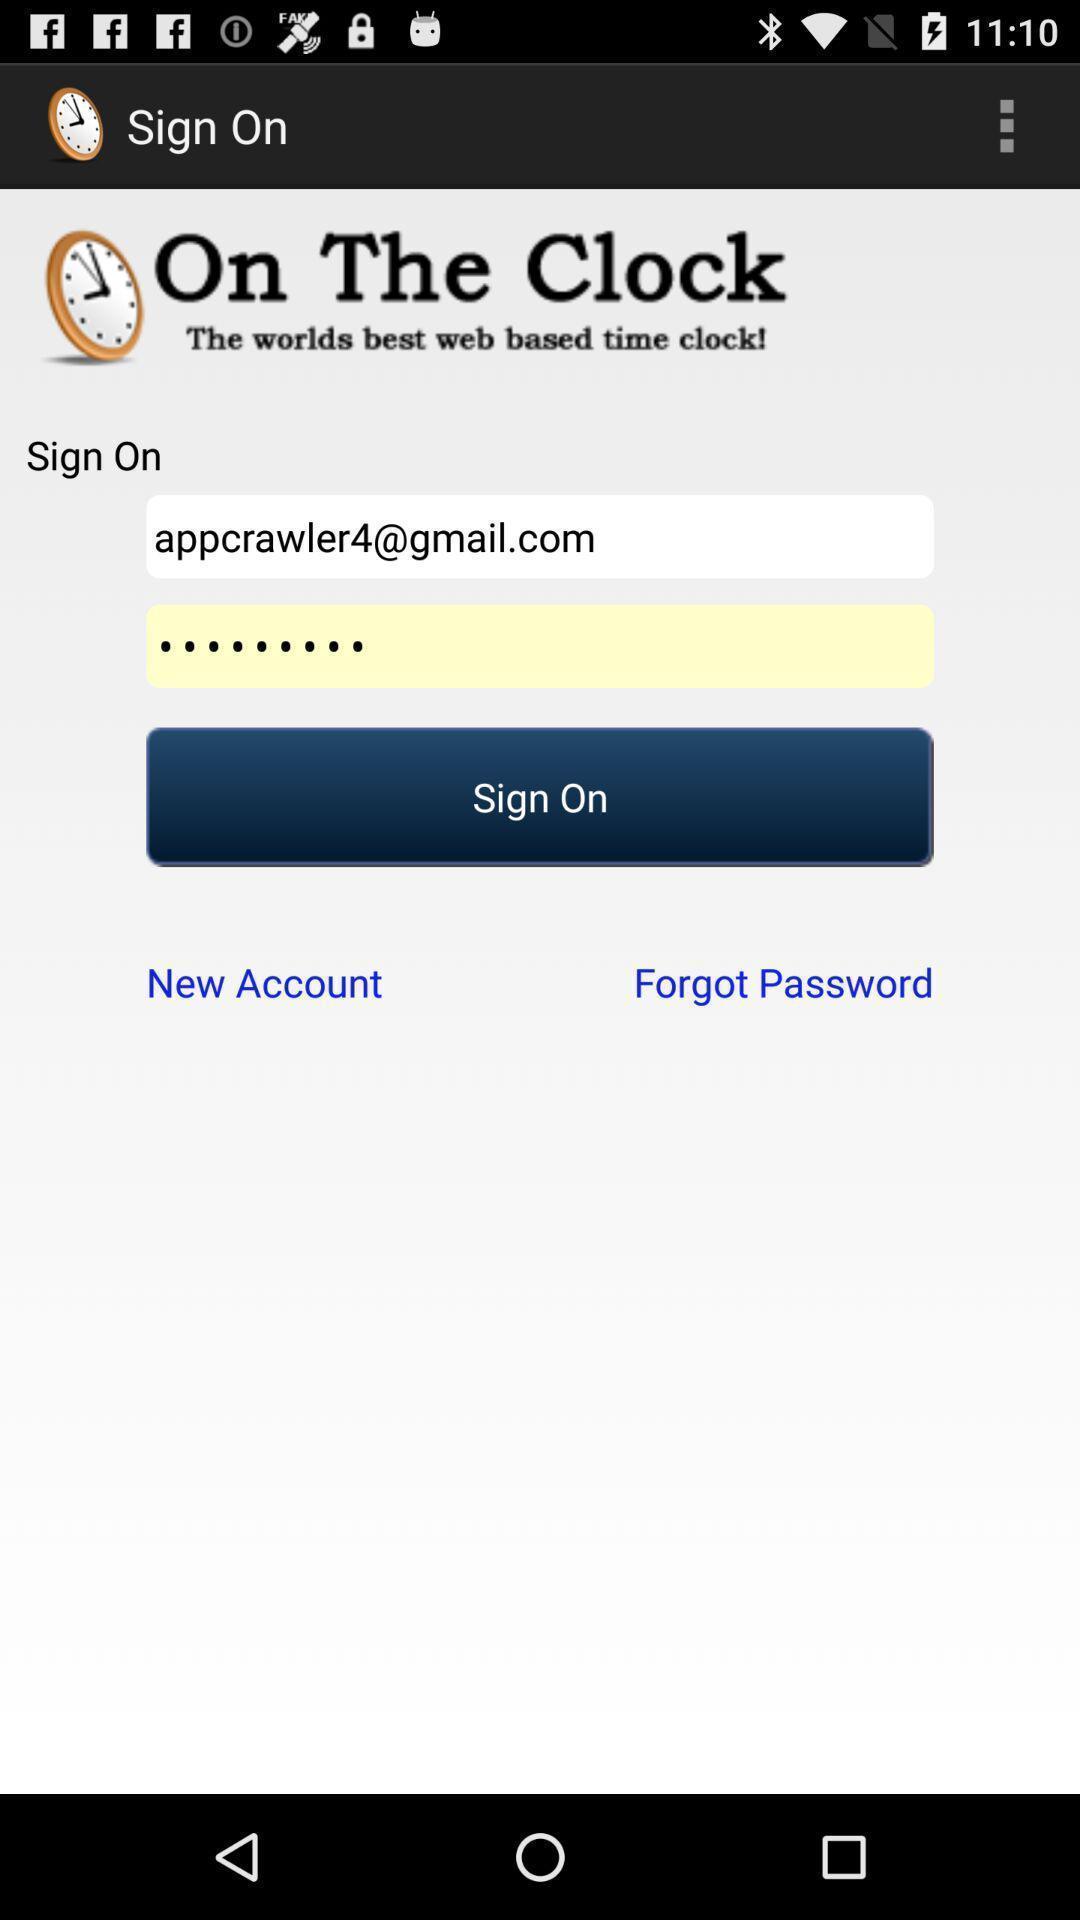Describe this image in words. Sign-in page of a time tracking app. 